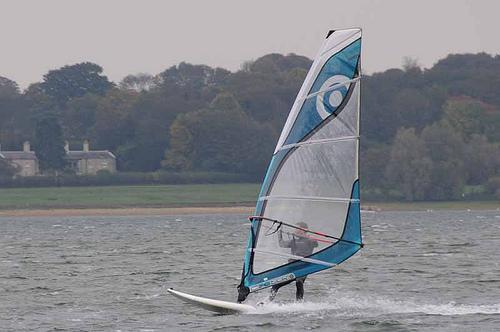Question: why are the waves choppy?
Choices:
A. It is raining.
B. It is very windy.
C. It is stormy.
D. High tide.
Answer with the letter. Answer: B Question: how is the man holding on?
Choices:
A. Hes doing good.
B. With his arms.
C. He just let go.
D. I have no clue.
Answer with the letter. Answer: B Question: who took the photo?
Choices:
A. My mom.
B. A professional photographer.
C. His wife.
D. Their son.
Answer with the letter. Answer: B Question: what is near the trees?
Choices:
A. A lake.
B. The shack.
C. A house.
D. The squirrell.
Answer with the letter. Answer: C Question: what is the man on?
Choices:
A. A skateboard.
B. A bus.
C. A surfboard with sail.
D. A boat.
Answer with the letter. Answer: C 